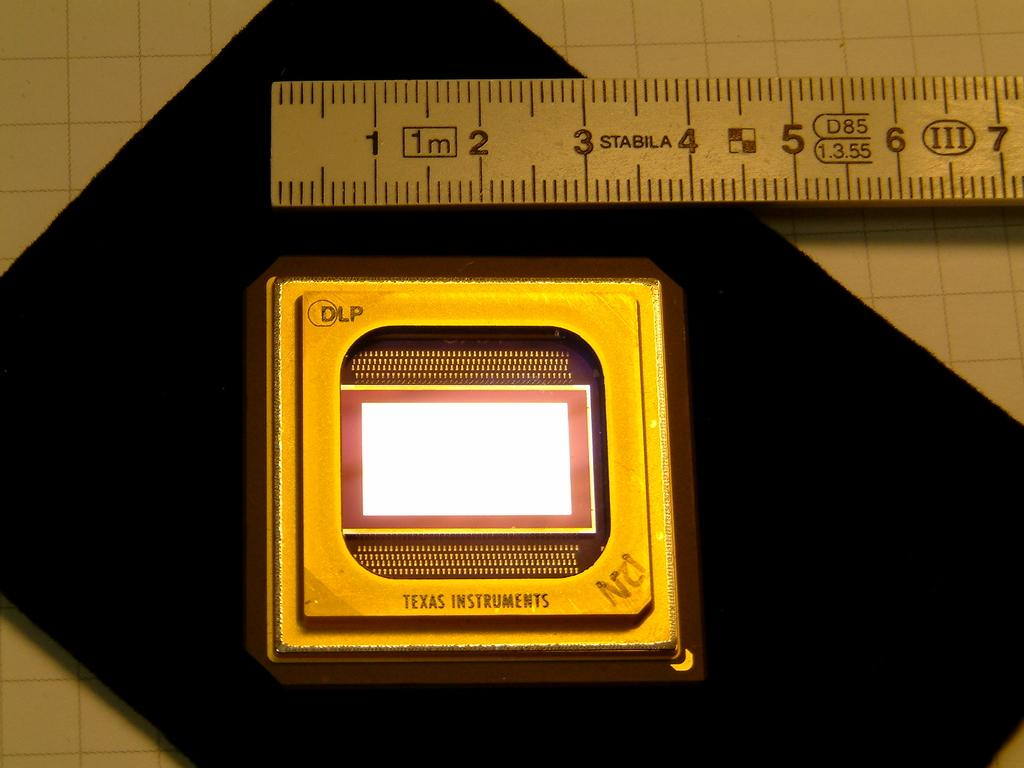<image>
Provide a brief description of the given image. A STABILA ruler measures an object at just under 4 units. 